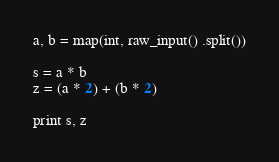Convert code to text. <code><loc_0><loc_0><loc_500><loc_500><_Python_>a, b = map(int, raw_input() .split())

s = a * b
z = (a * 2) + (b * 2)

print s, z</code> 